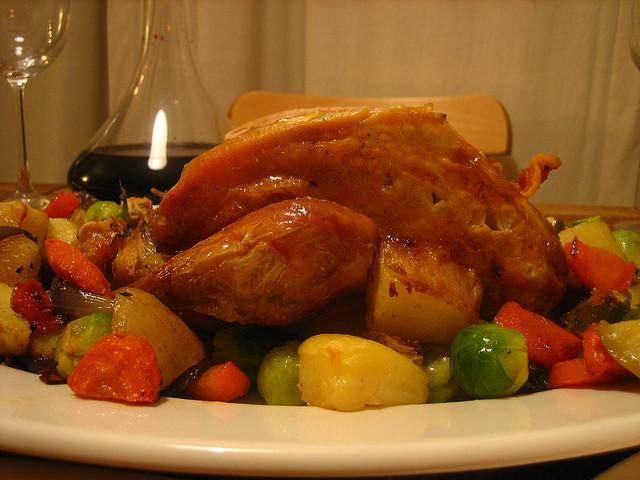What kind of protein is shown?
Concise answer only. Chicken. Is this meal healthy?
Keep it brief. Yes. What holiday mas this be?
Quick response, please. Thanksgiving. What kind of meal is shown?
Short answer required. Dinner. 